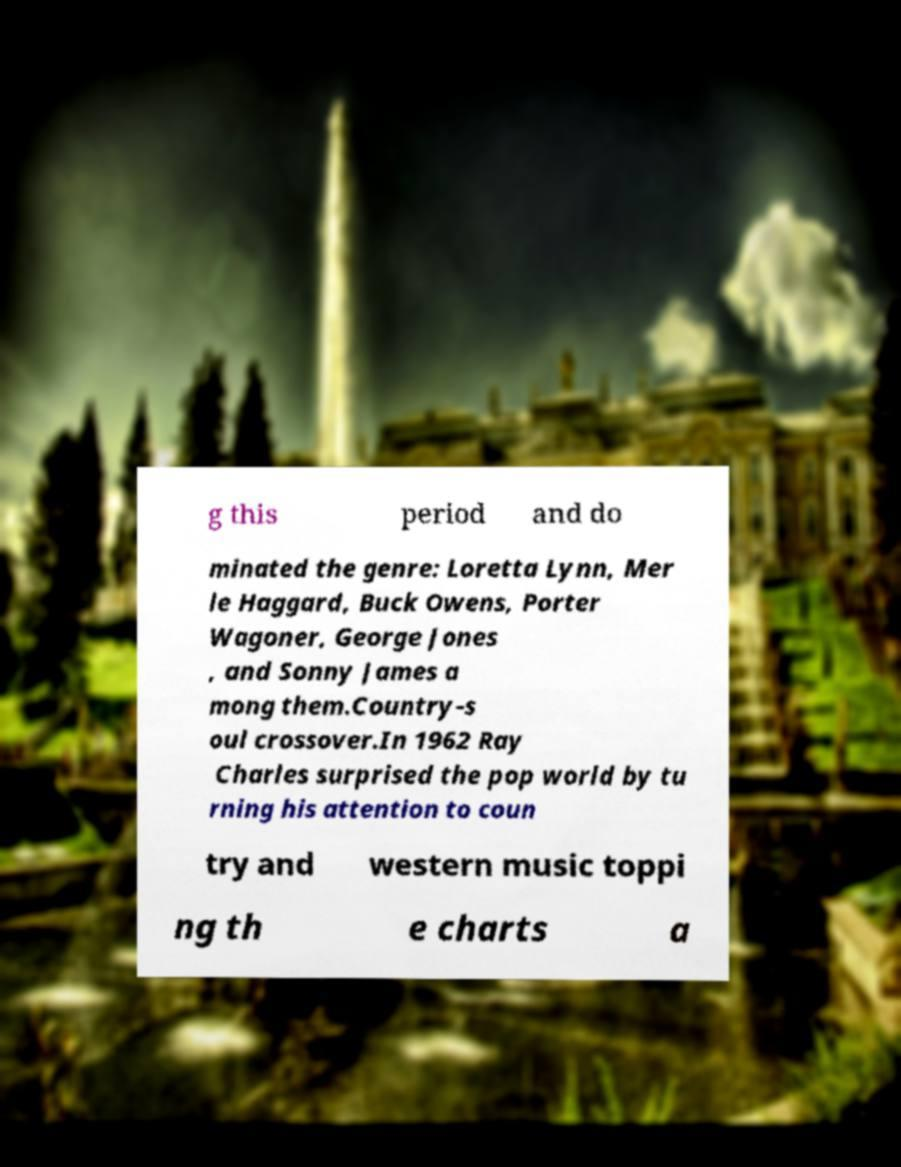Please read and relay the text visible in this image. What does it say? g this period and do minated the genre: Loretta Lynn, Mer le Haggard, Buck Owens, Porter Wagoner, George Jones , and Sonny James a mong them.Country-s oul crossover.In 1962 Ray Charles surprised the pop world by tu rning his attention to coun try and western music toppi ng th e charts a 